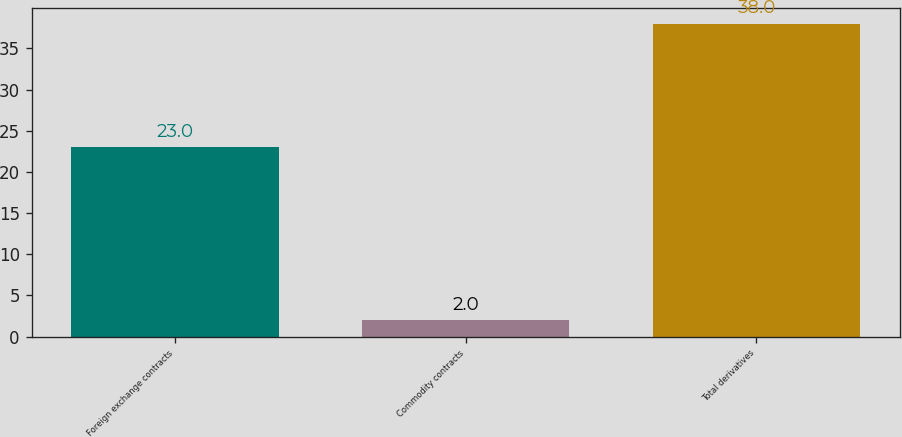Convert chart to OTSL. <chart><loc_0><loc_0><loc_500><loc_500><bar_chart><fcel>Foreign exchange contracts<fcel>Commodity contracts<fcel>Total derivatives<nl><fcel>23<fcel>2<fcel>38<nl></chart> 